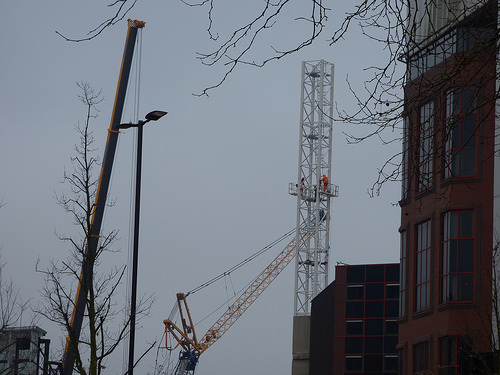<image>
Is the pole behind the building? No. The pole is not behind the building. From this viewpoint, the pole appears to be positioned elsewhere in the scene. 